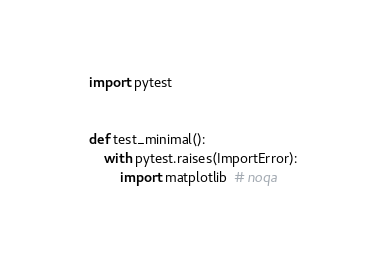<code> <loc_0><loc_0><loc_500><loc_500><_Python_>import pytest


def test_minimal():
    with pytest.raises(ImportError):
        import matplotlib  # noqa
</code> 